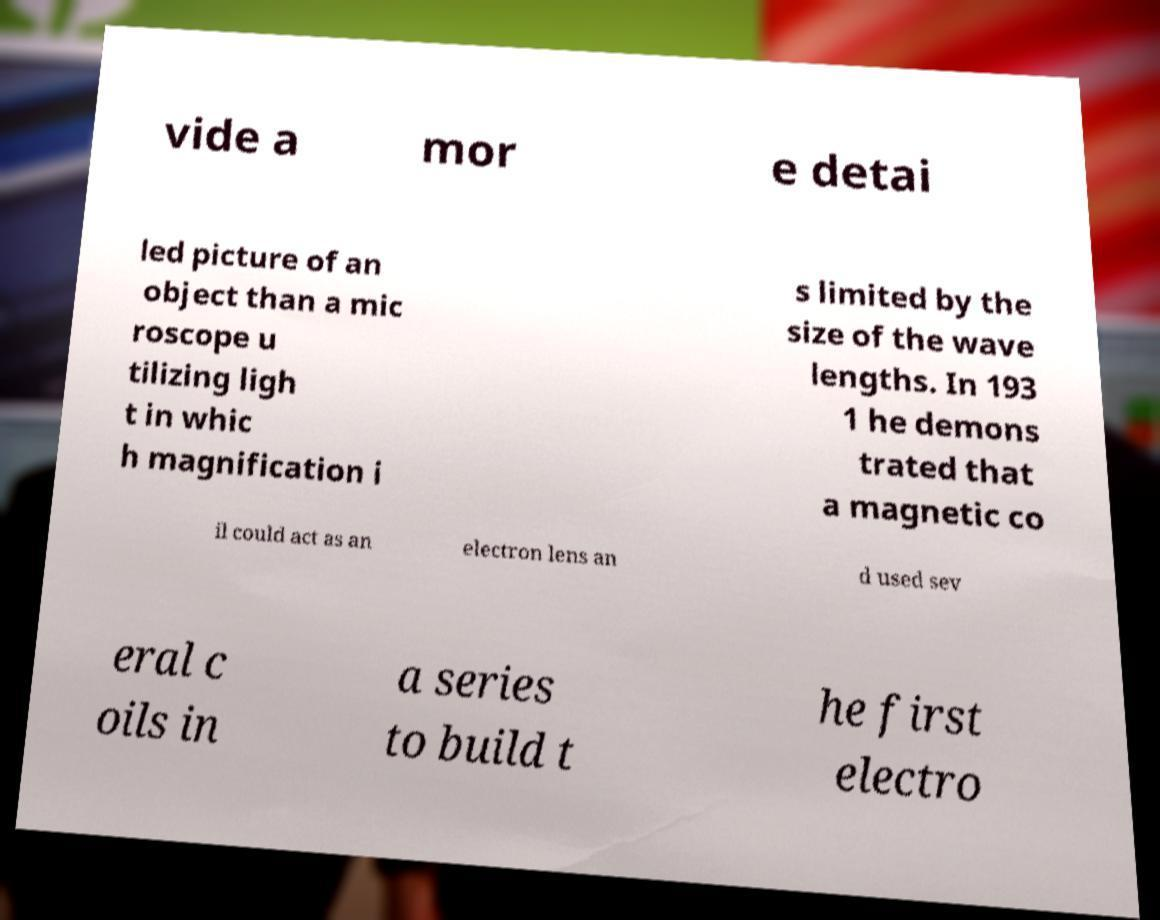What messages or text are displayed in this image? I need them in a readable, typed format. vide a mor e detai led picture of an object than a mic roscope u tilizing ligh t in whic h magnification i s limited by the size of the wave lengths. In 193 1 he demons trated that a magnetic co il could act as an electron lens an d used sev eral c oils in a series to build t he first electro 